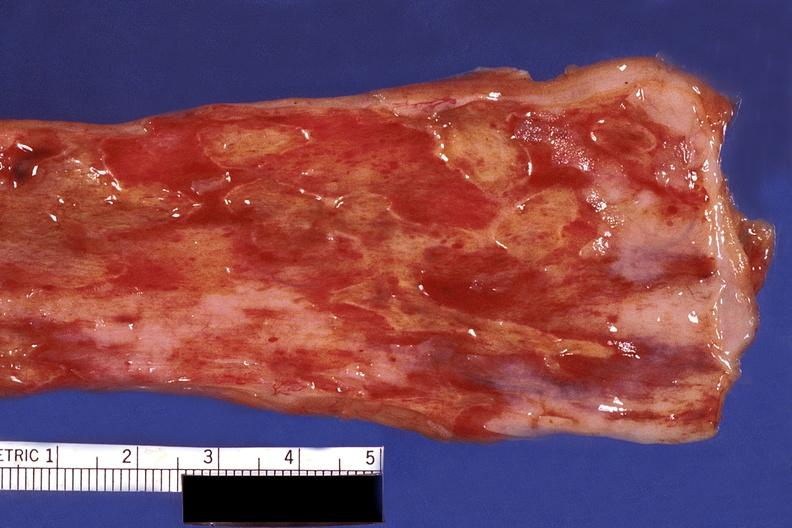what is present?
Answer the question using a single word or phrase. Gastrointestinal 